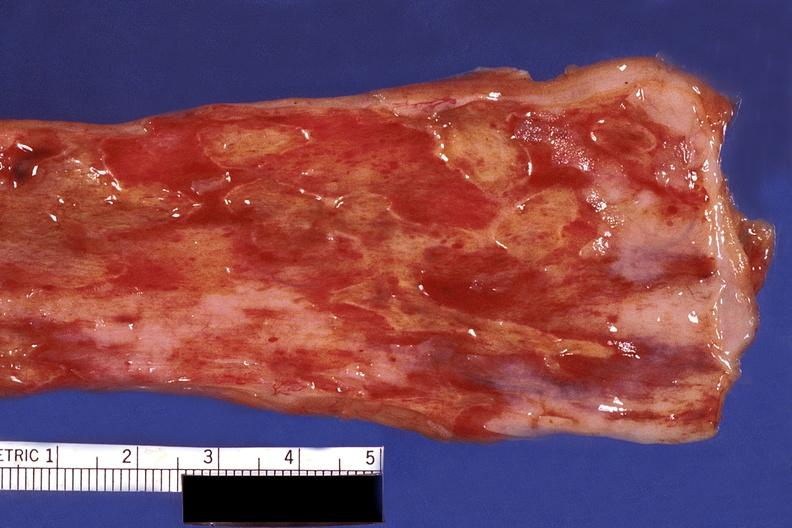what is present?
Answer the question using a single word or phrase. Gastrointestinal 